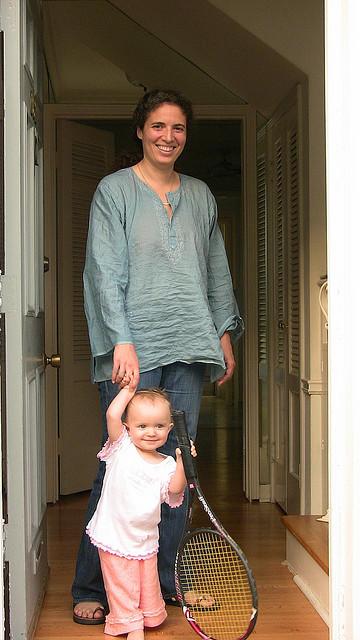What color are the pants?
Answer briefly. Pink and blue. How many babies are in the house?
Write a very short answer. 1. Who is holding the racket?
Quick response, please. Baby. 